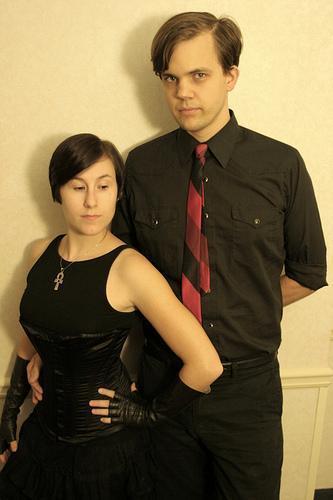How many people are there?
Give a very brief answer. 2. 